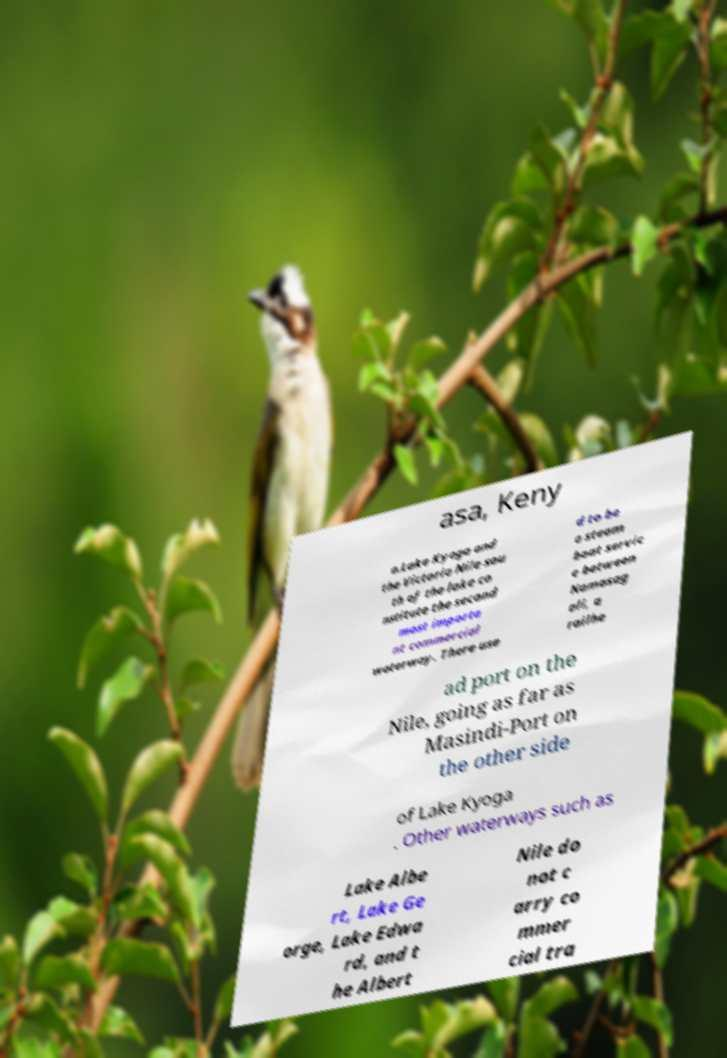Could you assist in decoding the text presented in this image and type it out clearly? asa, Keny a.Lake Kyoga and the Victoria Nile sou th of the lake co nstitute the second most importa nt commercial waterway. There use d to be a steam boat servic e between Namasag ali, a railhe ad port on the Nile, going as far as Masindi-Port on the other side of Lake Kyoga . Other waterways such as Lake Albe rt, Lake Ge orge, Lake Edwa rd, and t he Albert Nile do not c arry co mmer cial tra 